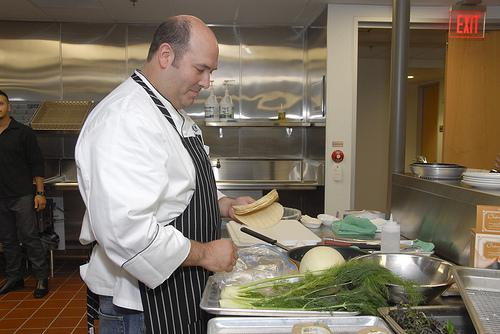Question: what is that round thing?
Choices:
A. A melon.
B. A ball.
C. A sucker.
D. A pancake.
Answer with the letter. Answer: A Question: what is he cooking?
Choices:
A. Cereal.
B. Meat.
C. Vegetables.
D. A pack of plants.
Answer with the letter. Answer: D Question: why is he in the kitchen?
Choices:
A. To clean up.
B. To make a meal.
C. To paint.
D. To fix sink.
Answer with the letter. Answer: B Question: where is he?
Choices:
A. In the kitchen.
B. In bedroom.
C. In bathroom.
D. In garage.
Answer with the letter. Answer: A 